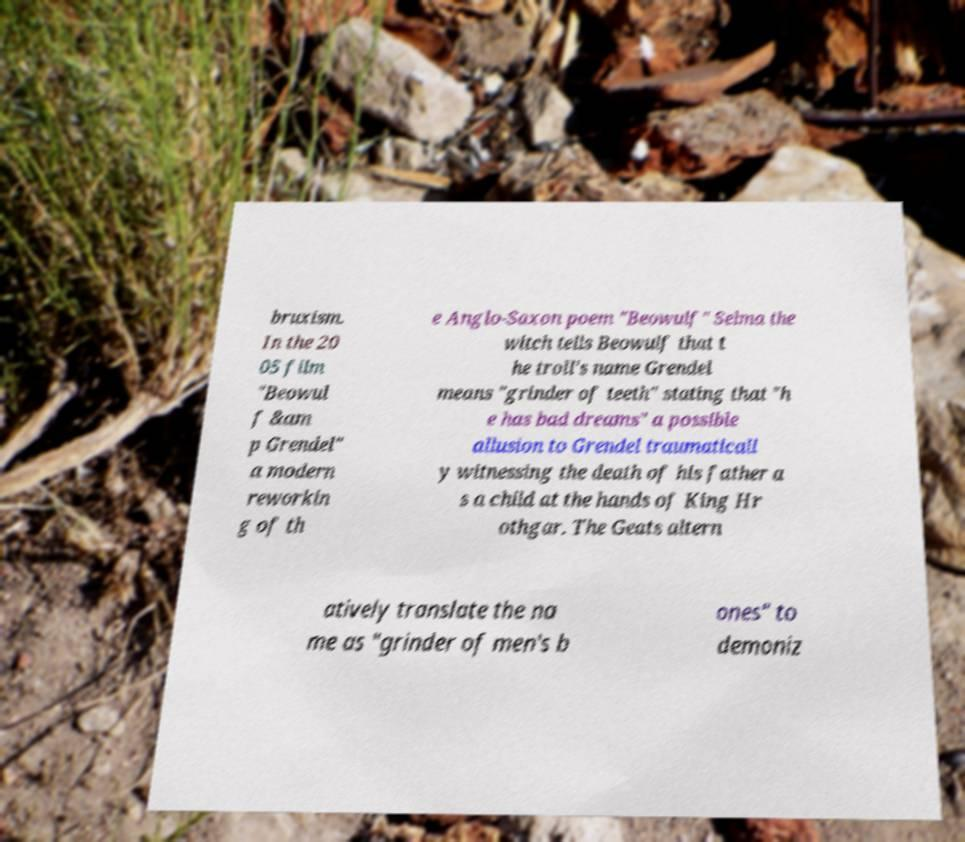Can you read and provide the text displayed in the image?This photo seems to have some interesting text. Can you extract and type it out for me? bruxism. In the 20 05 film "Beowul f &am p Grendel" a modern reworkin g of th e Anglo-Saxon poem "Beowulf" Selma the witch tells Beowulf that t he troll's name Grendel means "grinder of teeth" stating that "h e has bad dreams" a possible allusion to Grendel traumaticall y witnessing the death of his father a s a child at the hands of King Hr othgar. The Geats altern atively translate the na me as "grinder of men's b ones" to demoniz 